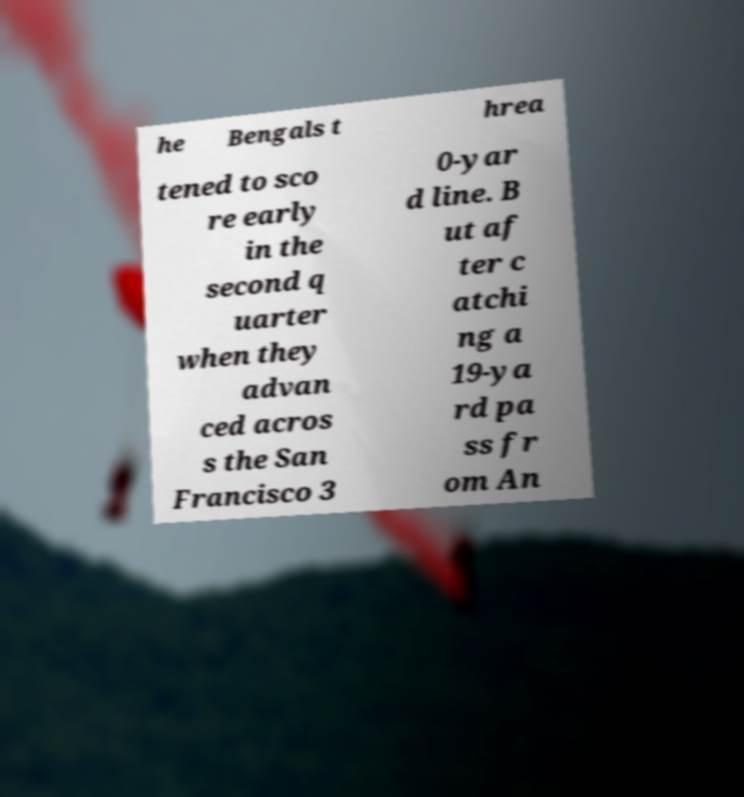Could you extract and type out the text from this image? he Bengals t hrea tened to sco re early in the second q uarter when they advan ced acros s the San Francisco 3 0-yar d line. B ut af ter c atchi ng a 19-ya rd pa ss fr om An 